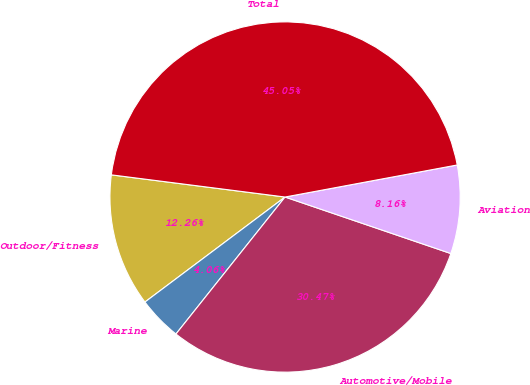Convert chart. <chart><loc_0><loc_0><loc_500><loc_500><pie_chart><fcel>Outdoor/Fitness<fcel>Marine<fcel>Automotive/Mobile<fcel>Aviation<fcel>Total<nl><fcel>12.26%<fcel>4.06%<fcel>30.48%<fcel>8.16%<fcel>45.06%<nl></chart> 